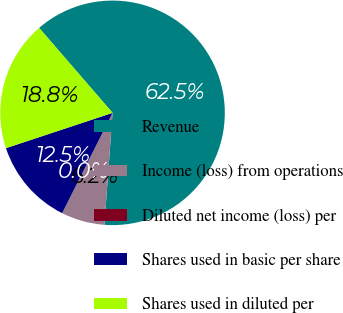Convert chart to OTSL. <chart><loc_0><loc_0><loc_500><loc_500><pie_chart><fcel>Revenue<fcel>Income (loss) from operations<fcel>Diluted net income (loss) per<fcel>Shares used in basic per share<fcel>Shares used in diluted per<nl><fcel>62.5%<fcel>6.25%<fcel>0.0%<fcel>12.5%<fcel>18.75%<nl></chart> 